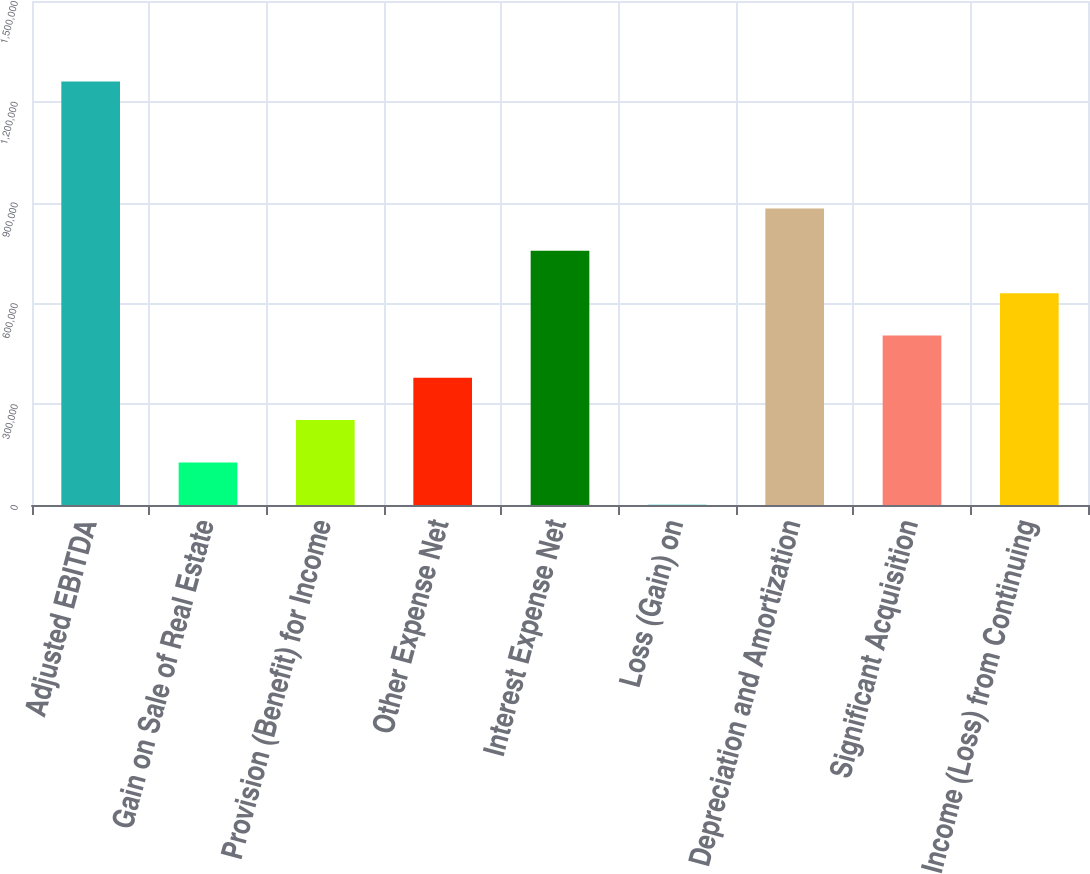<chart> <loc_0><loc_0><loc_500><loc_500><bar_chart><fcel>Adjusted EBITDA<fcel>Gain on Sale of Real Estate<fcel>Provision (Benefit) for Income<fcel>Other Expense Net<fcel>Interest Expense Net<fcel>Loss (Gain) on<fcel>Depreciation and Amortization<fcel>Significant Acquisition<fcel>Income (Loss) from Continuing<nl><fcel>1.2602e+06<fcel>126739<fcel>252678<fcel>378618<fcel>756437<fcel>799<fcel>882377<fcel>504558<fcel>630498<nl></chart> 